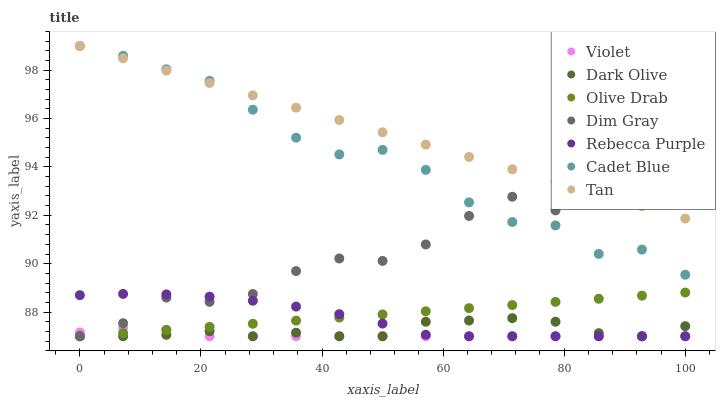Does Violet have the minimum area under the curve?
Answer yes or no. Yes. Does Tan have the maximum area under the curve?
Answer yes or no. Yes. Does Dark Olive have the minimum area under the curve?
Answer yes or no. No. Does Dark Olive have the maximum area under the curve?
Answer yes or no. No. Is Olive Drab the smoothest?
Answer yes or no. Yes. Is Dim Gray the roughest?
Answer yes or no. Yes. Is Dark Olive the smoothest?
Answer yes or no. No. Is Dark Olive the roughest?
Answer yes or no. No. Does Dark Olive have the lowest value?
Answer yes or no. Yes. Does Tan have the lowest value?
Answer yes or no. No. Does Tan have the highest value?
Answer yes or no. Yes. Does Dark Olive have the highest value?
Answer yes or no. No. Is Dark Olive less than Tan?
Answer yes or no. Yes. Is Cadet Blue greater than Olive Drab?
Answer yes or no. Yes. Does Dark Olive intersect Rebecca Purple?
Answer yes or no. Yes. Is Dark Olive less than Rebecca Purple?
Answer yes or no. No. Is Dark Olive greater than Rebecca Purple?
Answer yes or no. No. Does Dark Olive intersect Tan?
Answer yes or no. No. 